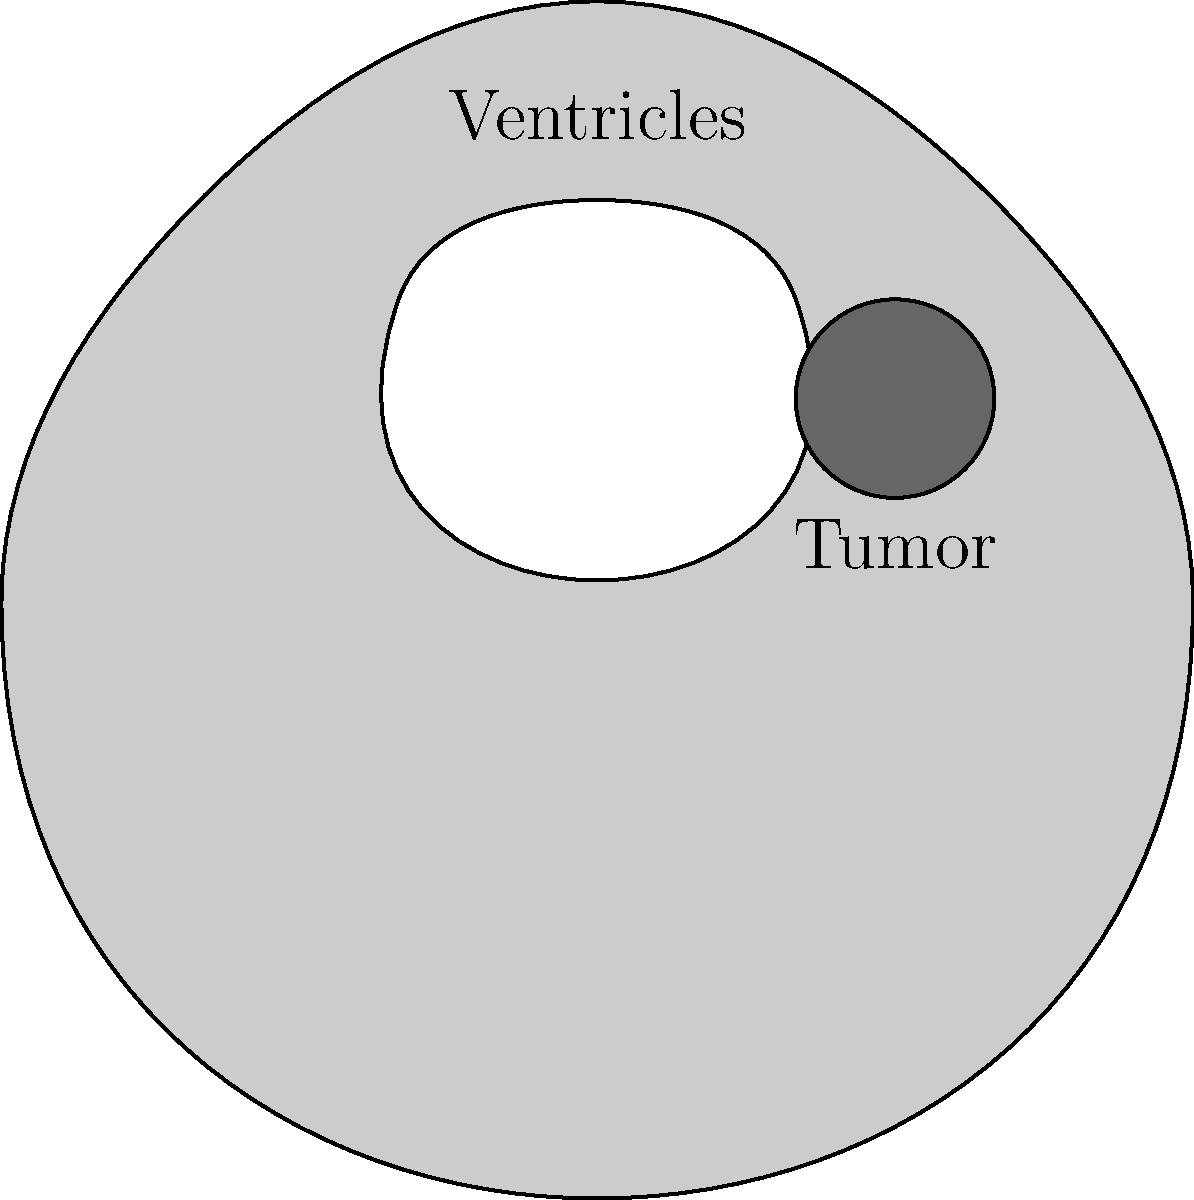In the CT scan image of the brain shown above, what neurological condition is most likely present based on the visible abnormality, and what additional symptoms might you expect the patient to exhibit? 1. Analyze the CT scan image:
   - The image shows a cross-section of the brain with visible ventricles and a dark, circular mass.
   - The dark mass is located in the right hemisphere, posterior to the ventricles.

2. Identify the abnormality:
   - The dark, circular mass is consistent with a brain tumor.
   - Its location suggests it's in the parietal or occipital lobe.

3. Determine the most likely neurological condition:
   - Based on the presence of a tumor-like mass, the most likely condition is a brain tumor.

4. Consider potential symptoms:
   - The tumor's location in the right hemisphere may affect the left side of the body.
   - Parietal lobe tumors can cause:
     a. Difficulty with spatial awareness
     b. Problems with sensation on the left side of the body
     c. Neglect of the left side of space
   - Occipital lobe tumors can cause:
     a. Visual disturbances or partial blindness in the left visual field
     b. Difficulty recognizing objects or colors

5. Additional general symptoms of brain tumors:
   - Headaches
   - Seizures
   - Cognitive changes
   - Nausea and vomiting
   - Balance and coordination problems
Answer: Brain tumor; potential symptoms include contralateral sensory deficits, visual disturbances, spatial awareness problems, headaches, and seizures. 